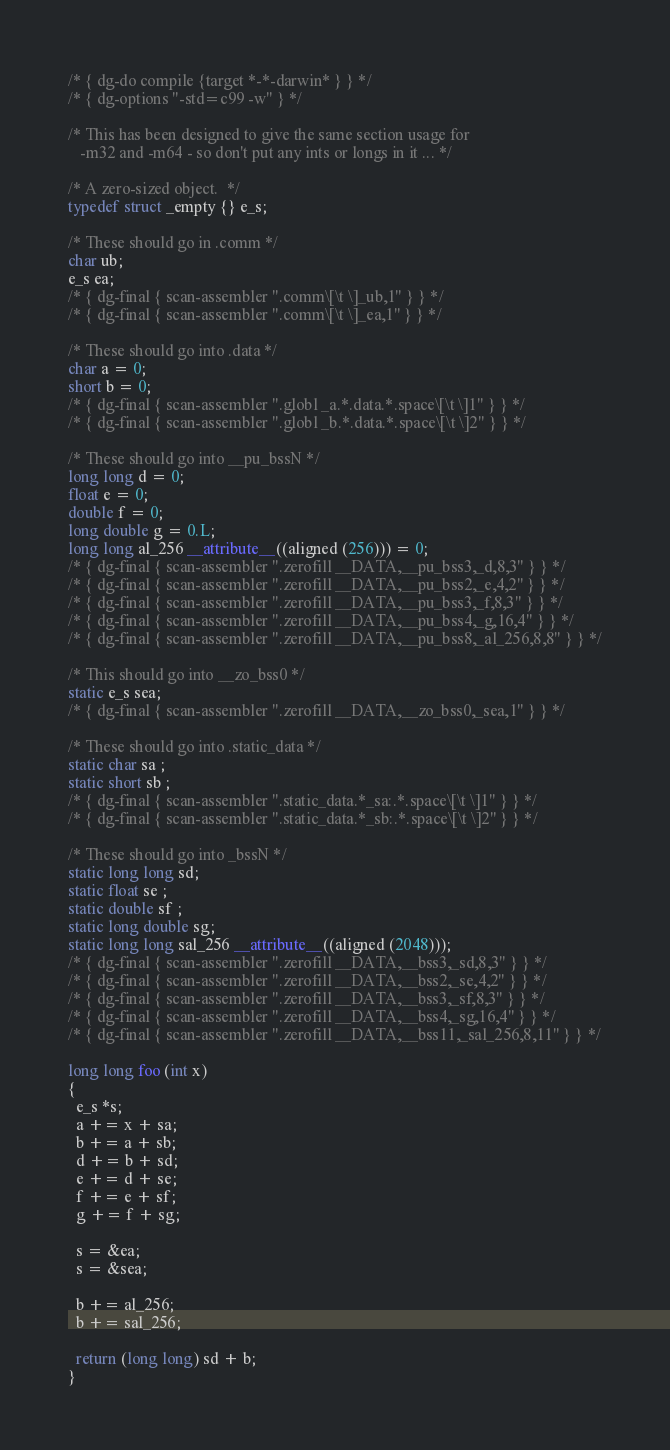<code> <loc_0><loc_0><loc_500><loc_500><_C_>/* { dg-do compile {target *-*-darwin* } } */
/* { dg-options "-std=c99 -w" } */

/* This has been designed to give the same section usage for
   -m32 and -m64 - so don't put any ints or longs in it ... */

/* A zero-sized object.  */
typedef struct _empty {} e_s;

/* These should go in .comm */
char ub;
e_s ea;
/* { dg-final { scan-assembler ".comm\[\t \]_ub,1" } } */
/* { dg-final { scan-assembler ".comm\[\t \]_ea,1" } } */

/* These should go into .data */
char a = 0;
short b = 0;
/* { dg-final { scan-assembler ".globl _a.*.data.*.space\[\t \]1" } } */
/* { dg-final { scan-assembler ".globl _b.*.data.*.space\[\t \]2" } } */

/* These should go into __pu_bssN */
long long d = 0;
float e = 0;
double f = 0;
long double g = 0.L;
long long al_256 __attribute__((aligned (256))) = 0;
/* { dg-final { scan-assembler ".zerofill __DATA,__pu_bss3,_d,8,3" } } */
/* { dg-final { scan-assembler ".zerofill __DATA,__pu_bss2,_e,4,2" } } */
/* { dg-final { scan-assembler ".zerofill __DATA,__pu_bss3,_f,8,3" } } */
/* { dg-final { scan-assembler ".zerofill __DATA,__pu_bss4,_g,16,4" } } */
/* { dg-final { scan-assembler ".zerofill __DATA,__pu_bss8,_al_256,8,8" } } */

/* This should go into __zo_bss0 */
static e_s sea;
/* { dg-final { scan-assembler ".zerofill __DATA,__zo_bss0,_sea,1" } } */

/* These should go into .static_data */
static char sa ;
static short sb ;
/* { dg-final { scan-assembler ".static_data.*_sa:.*.space\[\t \]1" } } */
/* { dg-final { scan-assembler ".static_data.*_sb:.*.space\[\t \]2" } } */

/* These should go into _bssN */
static long long sd;
static float se ;
static double sf ;
static long double sg;
static long long sal_256 __attribute__((aligned (2048)));
/* { dg-final { scan-assembler ".zerofill __DATA,__bss3,_sd,8,3" } } */
/* { dg-final { scan-assembler ".zerofill __DATA,__bss2,_se,4,2" } } */
/* { dg-final { scan-assembler ".zerofill __DATA,__bss3,_sf,8,3" } } */
/* { dg-final { scan-assembler ".zerofill __DATA,__bss4,_sg,16,4" } } */
/* { dg-final { scan-assembler ".zerofill __DATA,__bss11,_sal_256,8,11" } } */

long long foo (int x)
{
  e_s *s;
  a += x + sa;
  b += a + sb;
  d += b + sd;
  e += d + se;
  f += e + sf;
  g += f + sg;
 
  s = &ea;
  s = &sea;
  
  b += al_256;
  b += sal_256;

  return (long long) sd + b;
}
</code> 